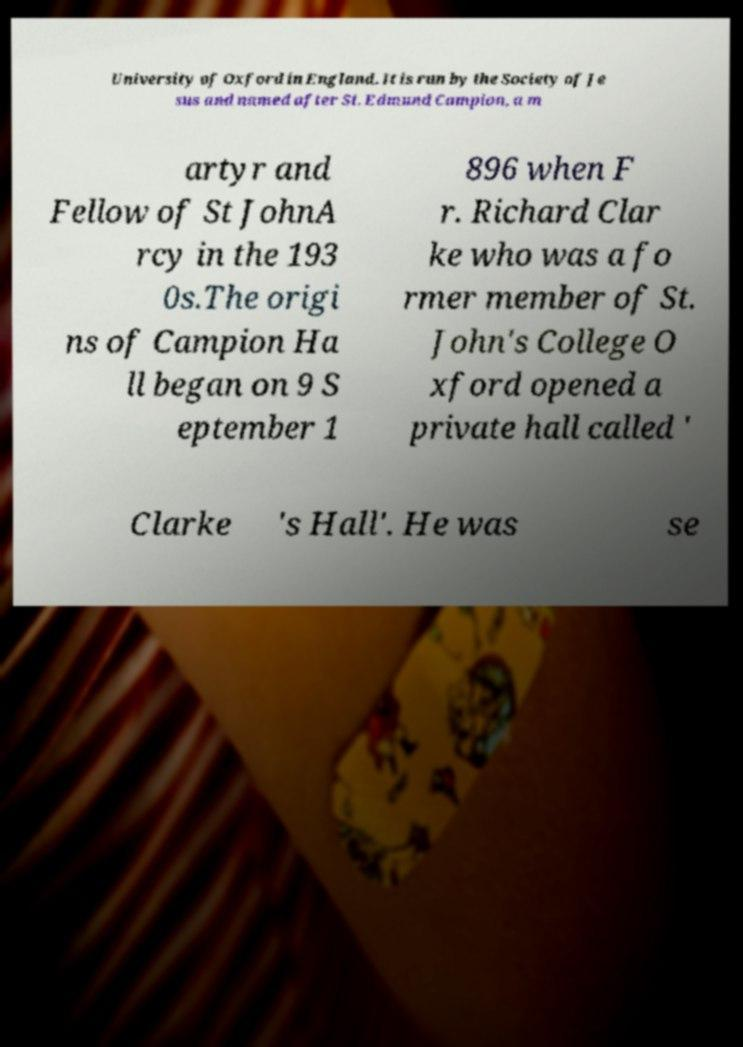What messages or text are displayed in this image? I need them in a readable, typed format. University of Oxford in England. It is run by the Society of Je sus and named after St. Edmund Campion, a m artyr and Fellow of St JohnA rcy in the 193 0s.The origi ns of Campion Ha ll began on 9 S eptember 1 896 when F r. Richard Clar ke who was a fo rmer member of St. John's College O xford opened a private hall called ' Clarke 's Hall'. He was se 